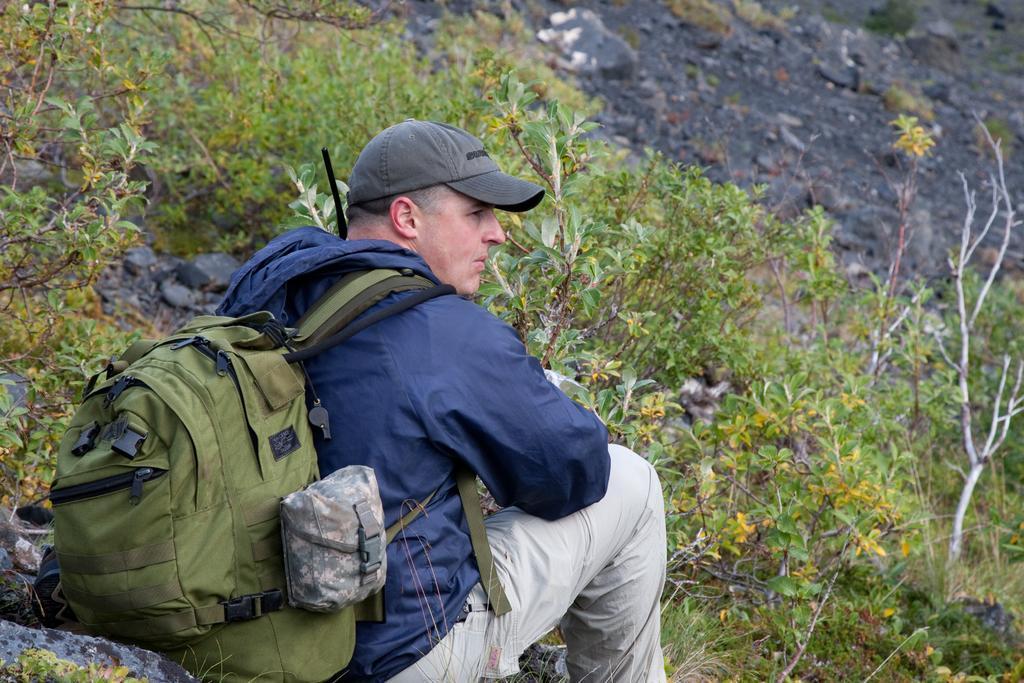Could you give a brief overview of what you see in this image? This image consists of plants and a man. He is having a backpack. He also has a cap. He is wearing blue color jacket. 